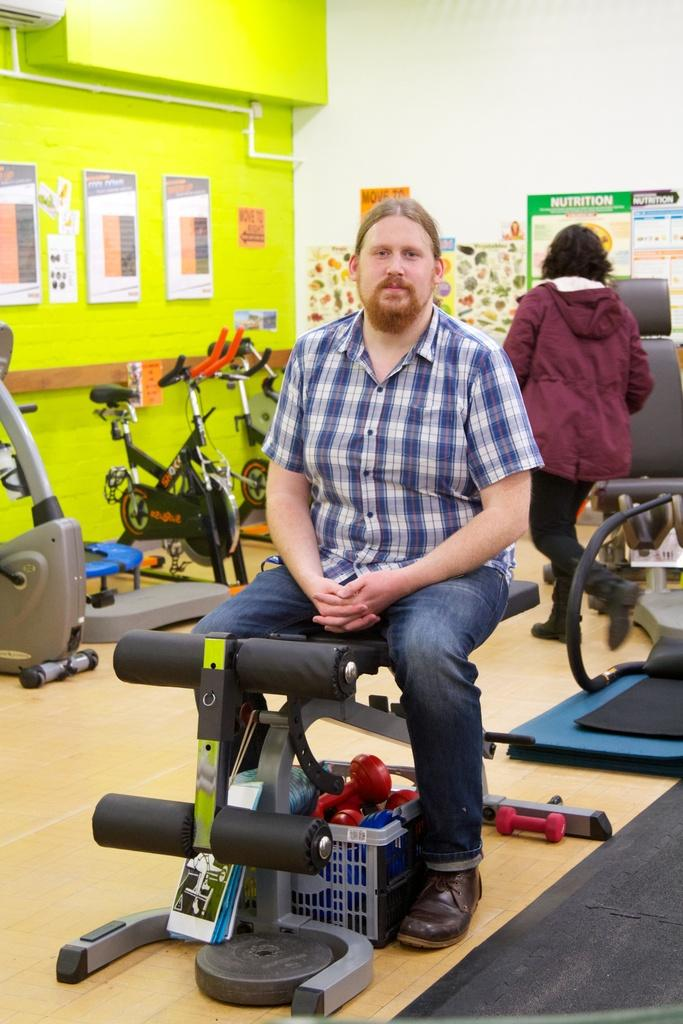What is the man in the foreground of the image doing? The man is sitting on an equipment in the foreground of the image. What can be seen in the background of the image? There are exercise bikes, a person, posters, and a pipe in the background of the image. What type of grass is growing on the plate in the image? There is no grass or plate present in the image. 